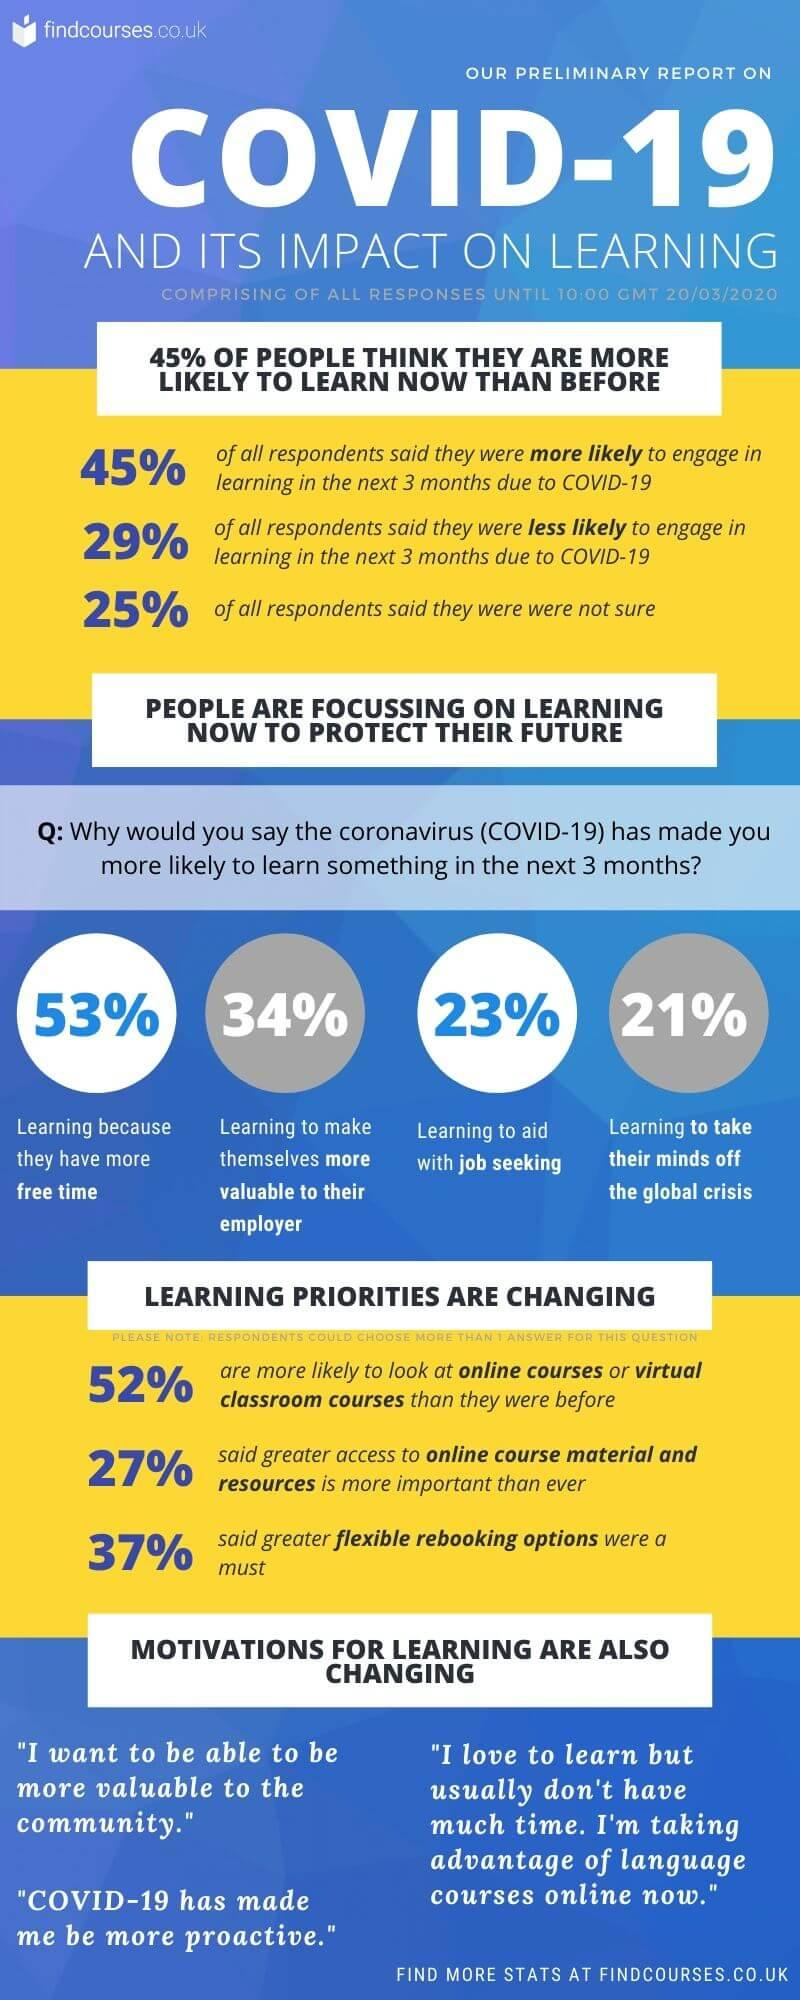Outline some significant characteristics in this image. According to a recent survey, 53% of people are learning because they have more free time. According to a recent survey, 21% of people are actively learning to divert their attention from the global crisis. According to the given statistics, 34% of people are actively learning to increase their value to their employer. According to a recent study, 23% of people are learning skills to assist with job seeking. 